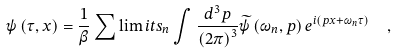<formula> <loc_0><loc_0><loc_500><loc_500>\psi \left ( \tau , x \right ) = \frac { 1 } { \beta } \sum \lim i t s _ { n } \int \frac { d ^ { 3 } p } { \left ( 2 \pi \right ) ^ { 3 } } \widetilde { \psi } \left ( \omega _ { n } , p \right ) e ^ { i \left ( p x + \omega _ { n } \tau \right ) } \ \ ,</formula> 